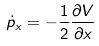Convert formula to latex. <formula><loc_0><loc_0><loc_500><loc_500>\dot { p } _ { x } = - \frac { 1 } { 2 } \frac { \partial V } { \partial x }</formula> 